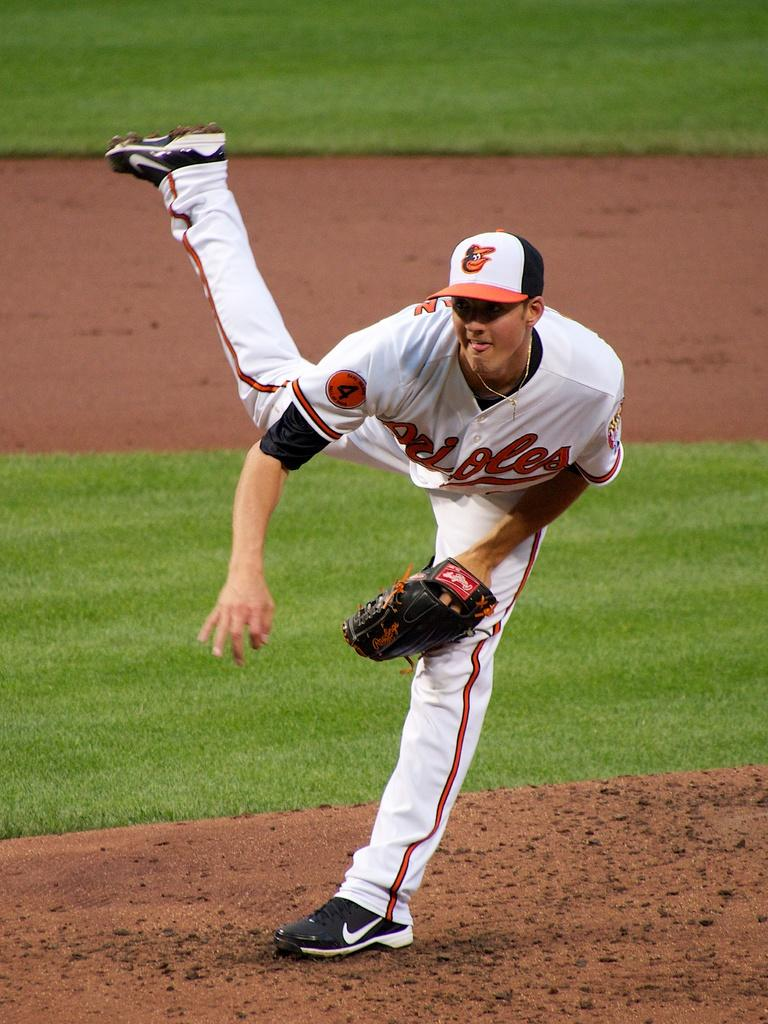Provide a one-sentence caption for the provided image. the number 4 player is pitching the ball. 